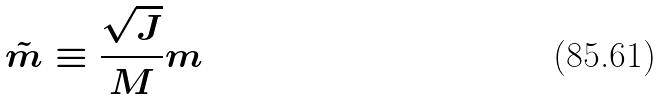<formula> <loc_0><loc_0><loc_500><loc_500>\tilde { m } \equiv \frac { \sqrt { J } } { M } m</formula> 